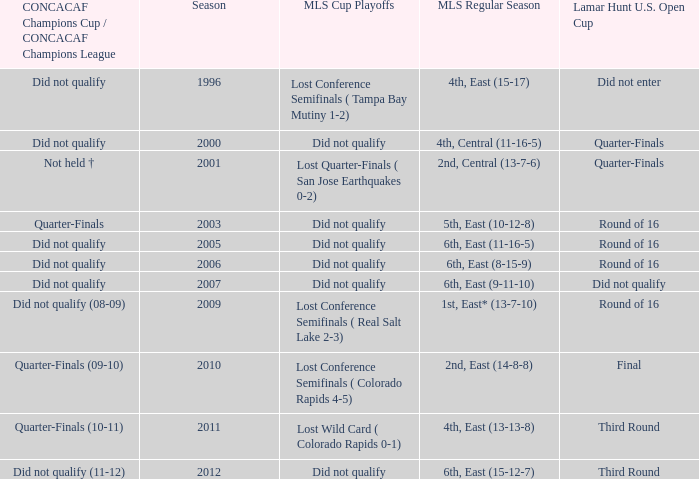What was the mls cup playoffs when the mls regular season was 4th, central (11-16-5)? Did not qualify. 